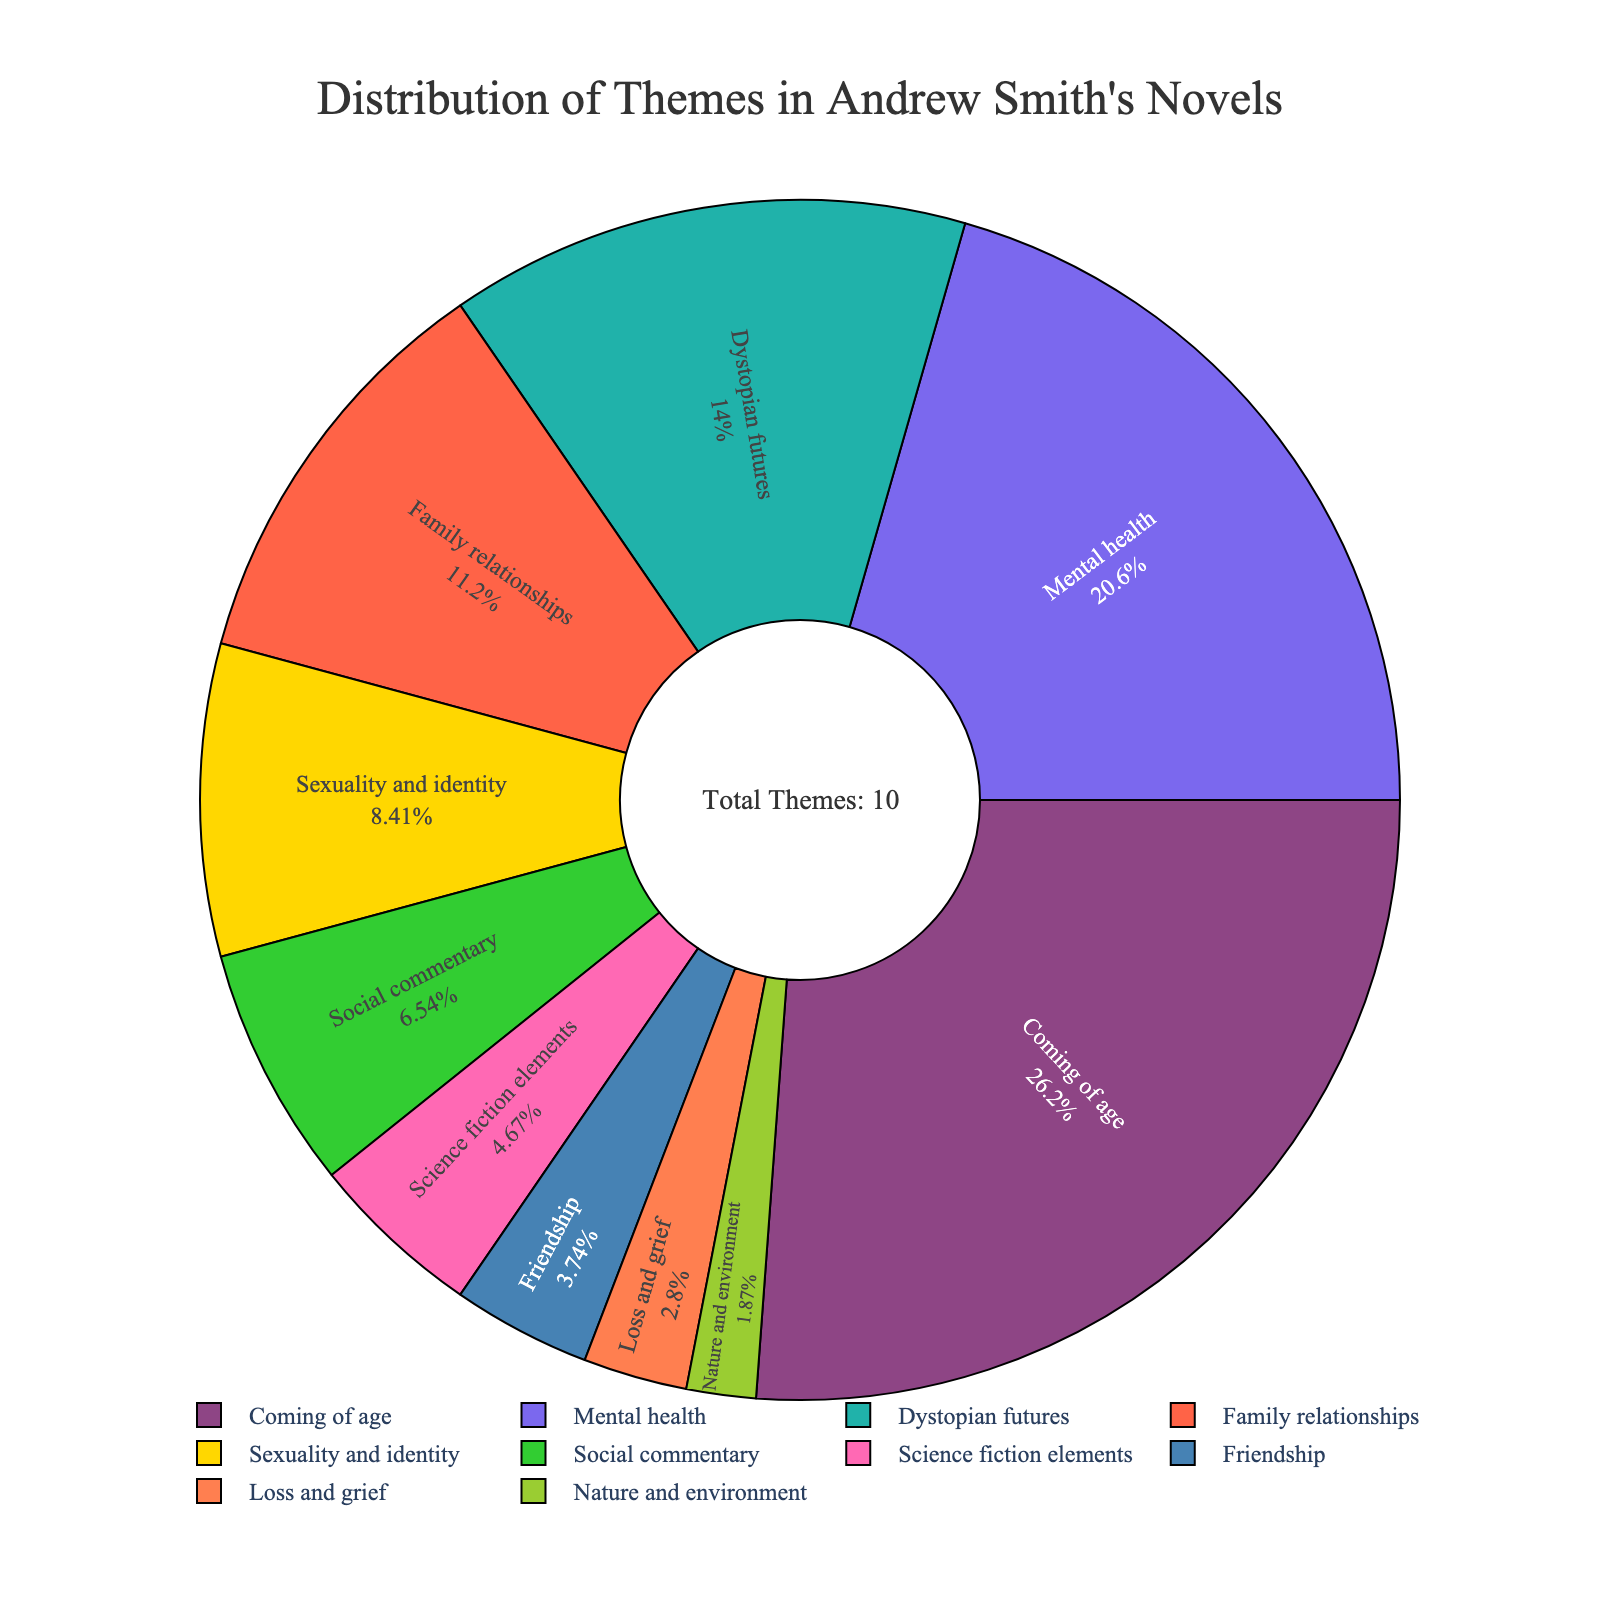What theme has the highest percentage in Andrew Smith's novels? The pie chart shows various themes, and the one with the largest segment represents the highest percentage. "Coming of age" occupies the largest segment.
Answer: Coming of age Which theme appears second most frequently in Andrew Smith's novels? The second-largest segment in the pie chart represents the theme that appears second most frequently. This segment corresponds to "Mental health."
Answer: Mental health What is the combined percentage of "Dystopian futures" and "Family relationships"? According to the pie chart, "Dystopian futures" has 15% and "Family relationships" has 12%. Adding these together: 15% + 12% = 27%.
Answer: 27% How does the percentage of "Sexuality and identity" compare to "Social commentary"? The pie chart shows "Sexuality and identity" at 9% and "Social commentary" at 7%. Therefore, "Sexuality and identity" has a higher percentage.
Answer: Sexuality and identity What is the least represented theme in Andrew Smith's novels? The smallest segment of the pie chart corresponds to the least represented theme, which is "Nature and environment" at 2%.
Answer: Nature and environment Which two themes together make up more than half of the total percentage? The two largest segments are "Coming of age" at 28% and "Mental health" at 22%. Adding these together: 28% + 22% = 50%. Therefore, these themes combined make up half of the total percentage.
Answer: Coming of age and Mental health What is the difference in percentage between "Science fiction elements" and "Friendship"? The pie chart shows "Science fiction elements" at 5% and "Friendship" at 4%. Subtracting these gives 5% - 4% = 1%.
Answer: 1% What is the median percentage of the themes? Listing the percentages in ascending order: 2, 3, 4, 5, 7, 9, 12, 15, 22, 28. The median is the middle value. Since there are 10 values, the median is the average of the 5th and 6th values: (7 + 9) / 2 = 8%.
Answer: 8% Identify the theme with a green-colored segment and its percentage. The pie chart indicates that "Science fiction elements" has a green-colored segment. The percentage for "Science fiction elements" is 5%.
Answer: Science fiction elements, 5% How much larger is the "Coming of age" theme compared to the "Loss and grief" theme? "Coming of age" has 28% and "Loss and grief" has 3%. The difference is 28% - 3% = 25%.
Answer: 25% 